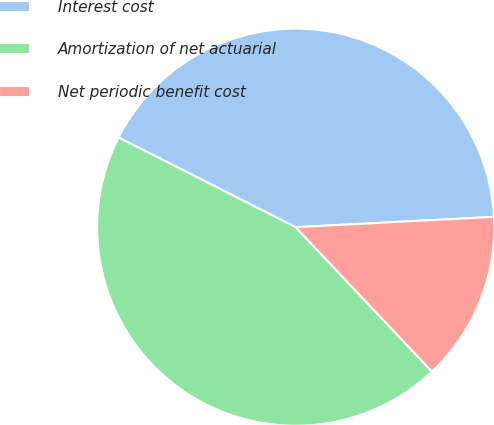Convert chart. <chart><loc_0><loc_0><loc_500><loc_500><pie_chart><fcel>Interest cost<fcel>Amortization of net actuarial<fcel>Net periodic benefit cost<nl><fcel>41.71%<fcel>44.5%<fcel>13.79%<nl></chart> 